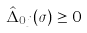<formula> <loc_0><loc_0><loc_500><loc_500>\hat { \Delta } _ { 0 j } ( \sigma ) \geq 0</formula> 